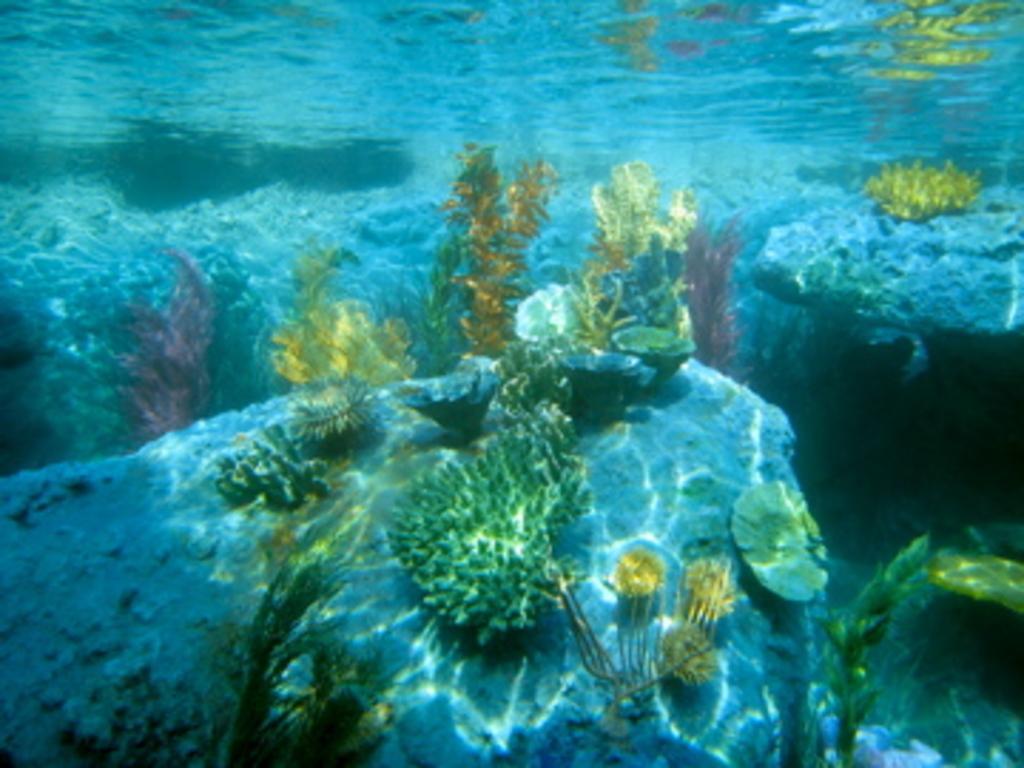How would you summarize this image in a sentence or two? In this picture there is water around the area of the image and there are aquatic plants in the center of the image. 